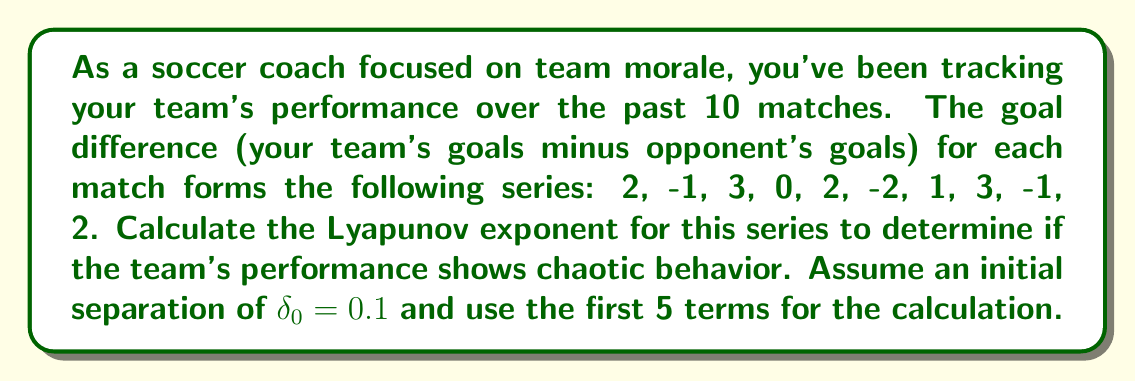Could you help me with this problem? To calculate the Lyapunov exponent for the given series, we'll follow these steps:

1) The Lyapunov exponent $\lambda$ is given by:

   $$\lambda = \lim_{n \to \infty} \frac{1}{n} \sum_{i=1}^n \ln\left|\frac{f'(x_i)}{f'(x_0)}\right|$$

   Where $f'(x)$ is the derivative of the function describing the system.

2) In our case, we don't have an explicit function, so we'll use the finite difference method to approximate the derivative:

   $$f'(x_i) \approx \frac{x_{i+1} - x_i}{\delta_0}$$

3) Calculate the differences for the first 5 terms:
   $f'(x_1) \approx \frac{-1 - 2}{0.1} = -30$
   $f'(x_2) \approx \frac{3 - (-1)}{0.1} = 40$
   $f'(x_3) \approx \frac{0 - 3}{0.1} = -30$
   $f'(x_4) \approx \frac{2 - 0}{0.1} = 20$
   $f'(x_5) \approx \frac{-2 - 2}{0.1} = -40$

4) Now, let's calculate the sum inside the Lyapunov exponent formula:

   $$\sum_{i=1}^5 \ln\left|\frac{f'(x_i)}{f'(x_1)}\right| = \ln\left|\frac{40}{-30}\right| + \ln\left|\frac{-30}{-30}\right| + \ln\left|\frac{20}{-30}\right| + \ln\left|\frac{-40}{-30}\right|$$

5) Simplify:
   $$= \ln\left|\frac{-4}{3}\right| + \ln|1| + \ln\left|\frac{-2}{3}\right| + \ln\left|\frac{4}{3}\right|$$
   $$= \ln\frac{4}{3} + 0 + \ln\frac{2}{3} + \ln\frac{4}{3}$$

6) Calculate:
   $$\approx 0.2877 + 0 - 0.4055 + 0.2877 = 0.1699$$

7) Finally, divide by n (5 in this case) to get the Lyapunov exponent:

   $$\lambda \approx \frac{0.1699}{5} = 0.03398$$
Answer: $\lambda \approx 0.03398$ 